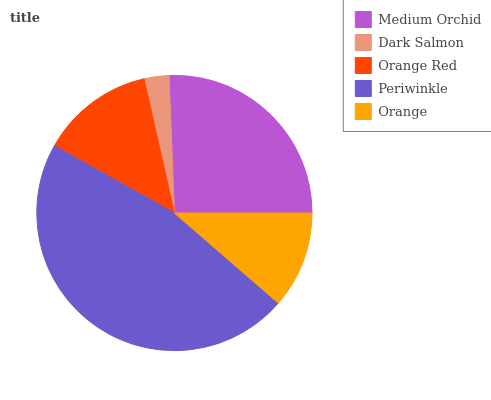Is Dark Salmon the minimum?
Answer yes or no. Yes. Is Periwinkle the maximum?
Answer yes or no. Yes. Is Orange Red the minimum?
Answer yes or no. No. Is Orange Red the maximum?
Answer yes or no. No. Is Orange Red greater than Dark Salmon?
Answer yes or no. Yes. Is Dark Salmon less than Orange Red?
Answer yes or no. Yes. Is Dark Salmon greater than Orange Red?
Answer yes or no. No. Is Orange Red less than Dark Salmon?
Answer yes or no. No. Is Orange Red the high median?
Answer yes or no. Yes. Is Orange Red the low median?
Answer yes or no. Yes. Is Medium Orchid the high median?
Answer yes or no. No. Is Periwinkle the low median?
Answer yes or no. No. 